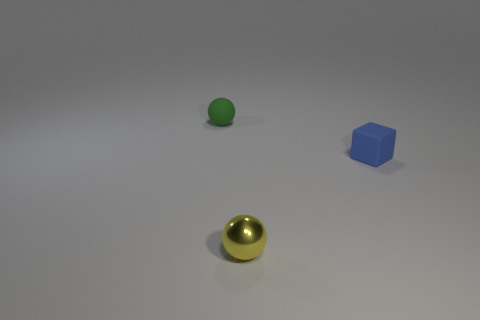Add 2 tiny green rubber things. How many objects exist? 5 Subtract all spheres. How many objects are left? 1 Subtract all yellow metal spheres. Subtract all yellow shiny things. How many objects are left? 1 Add 2 small green matte objects. How many small green matte objects are left? 3 Add 1 large red rubber cylinders. How many large red rubber cylinders exist? 1 Subtract 0 yellow cubes. How many objects are left? 3 